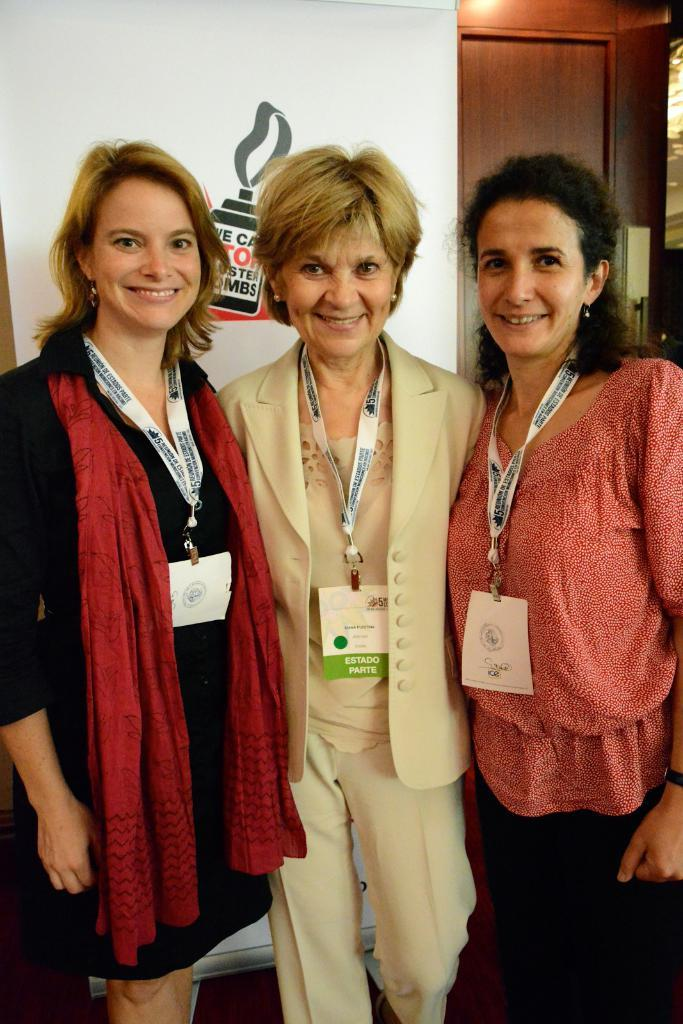What is on the wall in the background of the image? There is a poster on the wall in the background. What architectural feature can be seen in the image? There is a door visible in the image. Who is present in the image? There are women in the image. What are the women doing in the image? The women are standing and smiling. What type of hammer is being used by the women in the image? There is no hammer present in the image; the women are standing and smiling. What business-related activity is taking place in the image? There is no business-related activity depicted in the image; it simply shows women standing and smiling. 